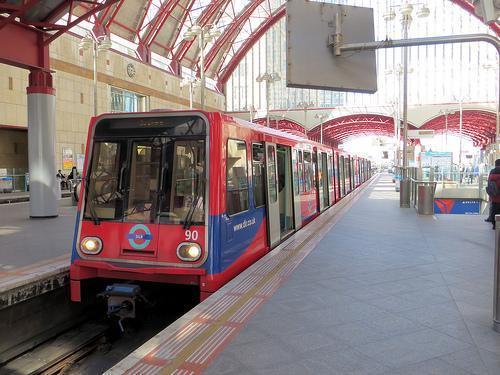How many trains are in the photo?
Give a very brief answer. 1. 